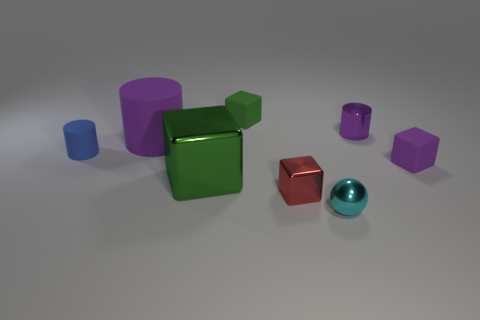What materials appear to be present in the objects shown? The objects in the image appear to have a matte finish, suggesting they might be made of a non-glossy plastic or a similar material with diffuse reflection properties. 